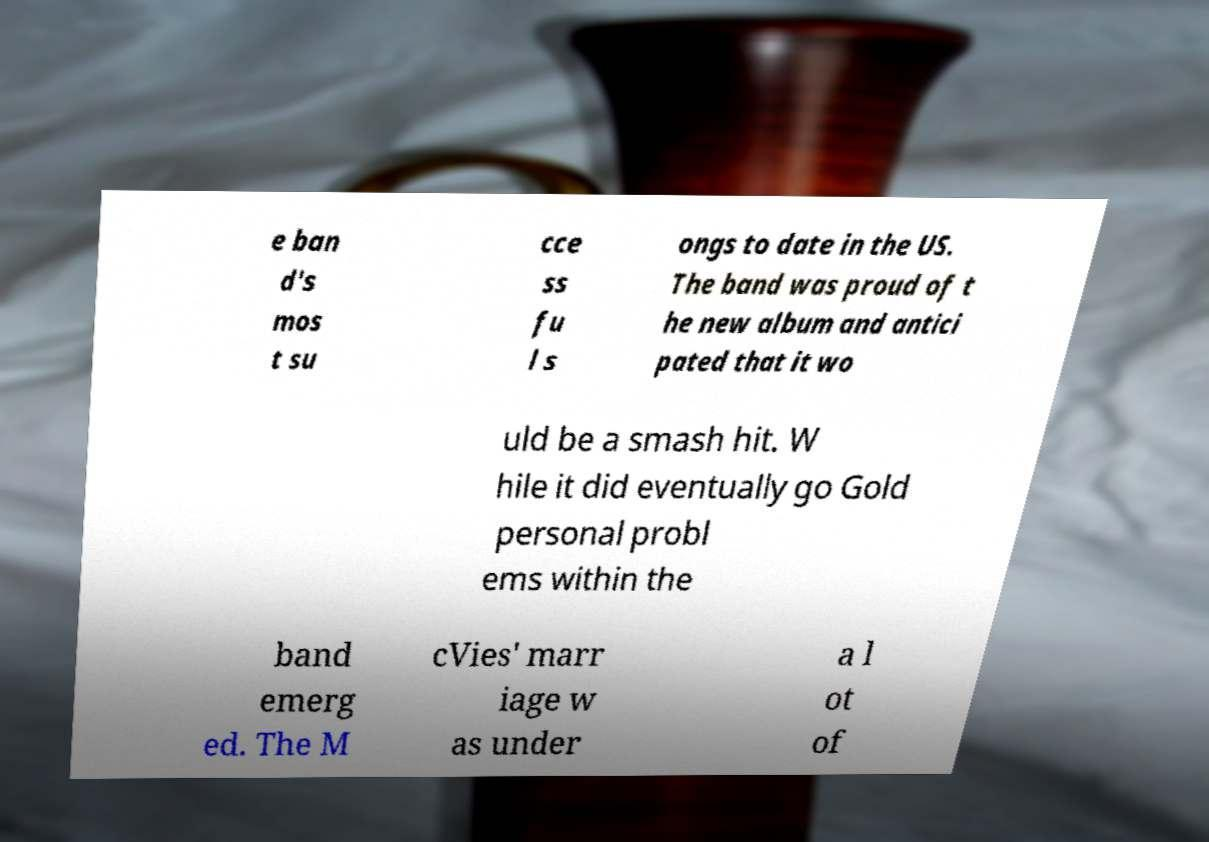Please identify and transcribe the text found in this image. e ban d's mos t su cce ss fu l s ongs to date in the US. The band was proud of t he new album and antici pated that it wo uld be a smash hit. W hile it did eventually go Gold personal probl ems within the band emerg ed. The M cVies' marr iage w as under a l ot of 